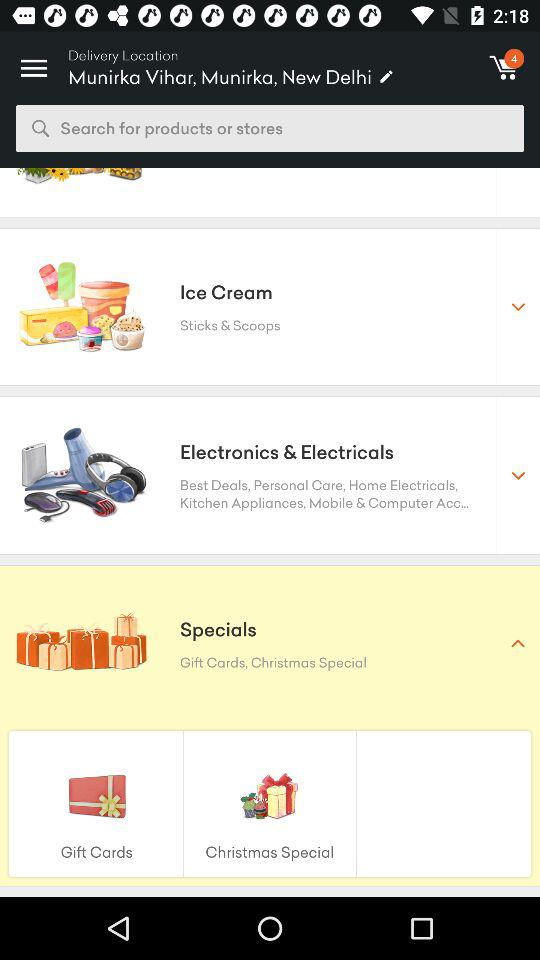How many items are in the shopping cart? There are 4 items in the shopping cart. 